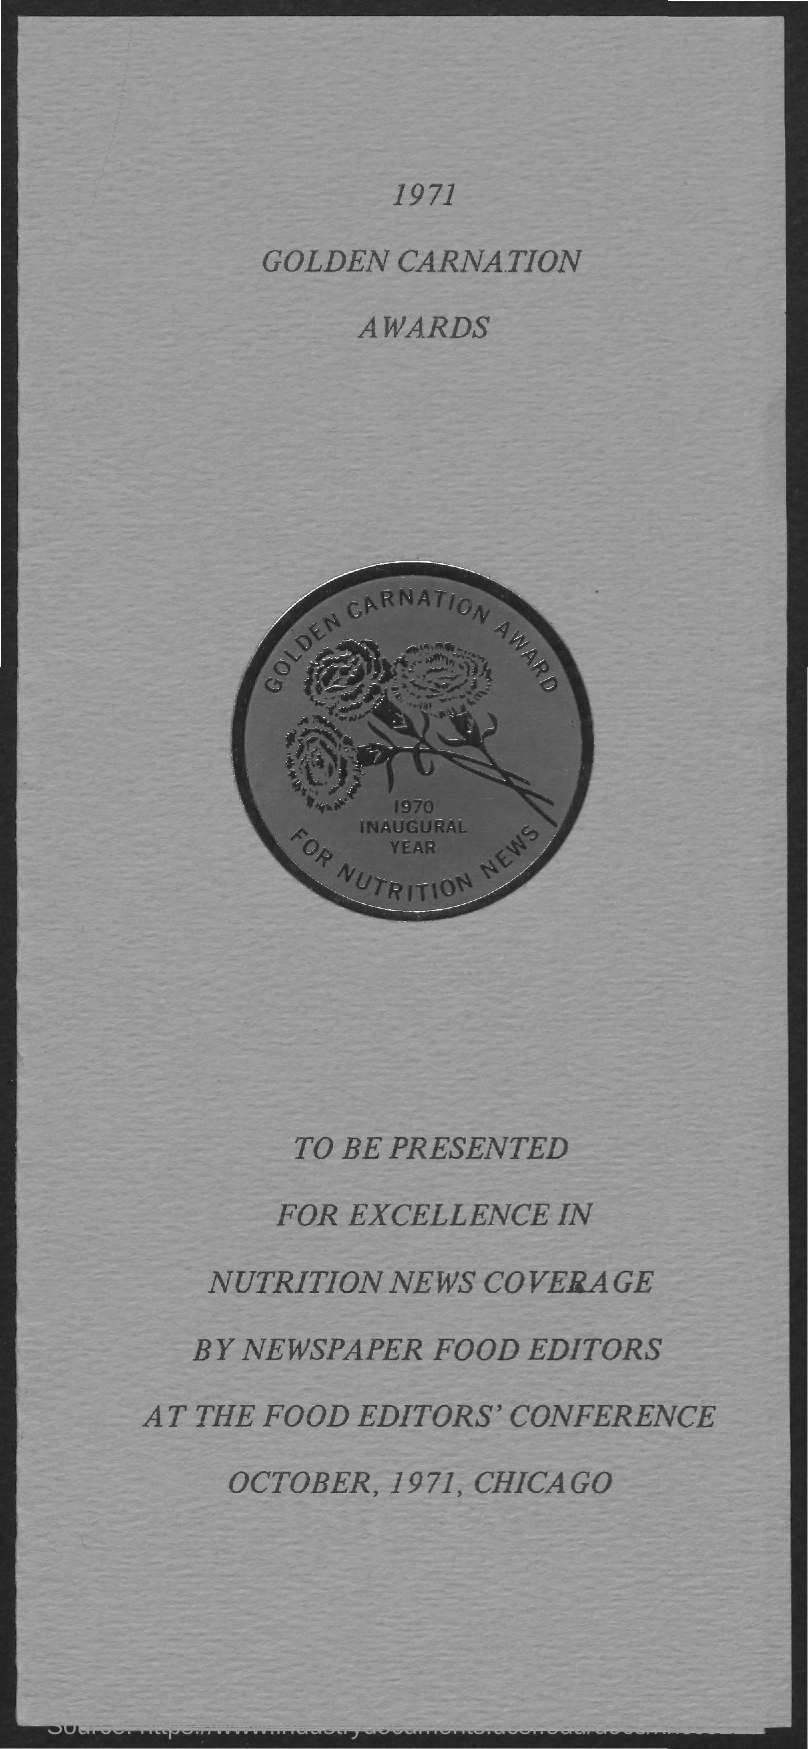Give some essential details in this illustration. The presentation took place in October, 1971. 